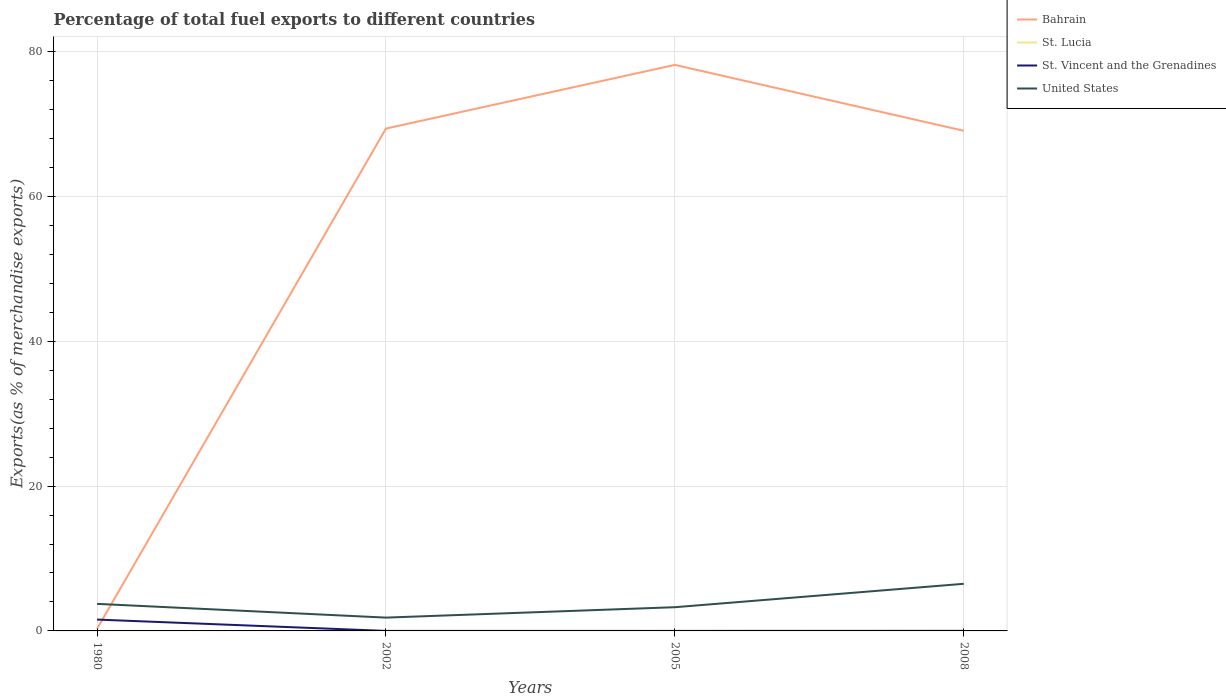How many different coloured lines are there?
Provide a short and direct response. 4. Does the line corresponding to Bahrain intersect with the line corresponding to United States?
Keep it short and to the point. Yes. Across all years, what is the maximum percentage of exports to different countries in United States?
Offer a very short reply. 1.84. What is the total percentage of exports to different countries in St. Lucia in the graph?
Offer a very short reply. -0.02. What is the difference between the highest and the second highest percentage of exports to different countries in St. Vincent and the Grenadines?
Keep it short and to the point. 1.57. Is the percentage of exports to different countries in Bahrain strictly greater than the percentage of exports to different countries in St. Lucia over the years?
Keep it short and to the point. No. Are the values on the major ticks of Y-axis written in scientific E-notation?
Offer a very short reply. No. Does the graph contain any zero values?
Offer a terse response. No. How many legend labels are there?
Make the answer very short. 4. What is the title of the graph?
Provide a short and direct response. Percentage of total fuel exports to different countries. Does "Middle East & North Africa (developing only)" appear as one of the legend labels in the graph?
Make the answer very short. No. What is the label or title of the X-axis?
Provide a succinct answer. Years. What is the label or title of the Y-axis?
Offer a very short reply. Exports(as % of merchandise exports). What is the Exports(as % of merchandise exports) in Bahrain in 1980?
Ensure brevity in your answer.  0.29. What is the Exports(as % of merchandise exports) of St. Lucia in 1980?
Your answer should be compact. 0.01. What is the Exports(as % of merchandise exports) of St. Vincent and the Grenadines in 1980?
Ensure brevity in your answer.  1.57. What is the Exports(as % of merchandise exports) in United States in 1980?
Your answer should be very brief. 3.74. What is the Exports(as % of merchandise exports) of Bahrain in 2002?
Make the answer very short. 69.37. What is the Exports(as % of merchandise exports) of St. Lucia in 2002?
Your answer should be compact. 4.657797227082891e-6. What is the Exports(as % of merchandise exports) in St. Vincent and the Grenadines in 2002?
Provide a short and direct response. 0. What is the Exports(as % of merchandise exports) in United States in 2002?
Make the answer very short. 1.84. What is the Exports(as % of merchandise exports) in Bahrain in 2005?
Offer a very short reply. 78.16. What is the Exports(as % of merchandise exports) in St. Lucia in 2005?
Your response must be concise. 0. What is the Exports(as % of merchandise exports) in St. Vincent and the Grenadines in 2005?
Ensure brevity in your answer.  0. What is the Exports(as % of merchandise exports) of United States in 2005?
Provide a succinct answer. 3.27. What is the Exports(as % of merchandise exports) in Bahrain in 2008?
Provide a short and direct response. 69.06. What is the Exports(as % of merchandise exports) of St. Lucia in 2008?
Provide a succinct answer. 0.02. What is the Exports(as % of merchandise exports) in St. Vincent and the Grenadines in 2008?
Your response must be concise. 0.01. What is the Exports(as % of merchandise exports) of United States in 2008?
Your answer should be compact. 6.51. Across all years, what is the maximum Exports(as % of merchandise exports) of Bahrain?
Give a very brief answer. 78.16. Across all years, what is the maximum Exports(as % of merchandise exports) of St. Lucia?
Your answer should be compact. 0.02. Across all years, what is the maximum Exports(as % of merchandise exports) of St. Vincent and the Grenadines?
Provide a succinct answer. 1.57. Across all years, what is the maximum Exports(as % of merchandise exports) in United States?
Provide a succinct answer. 6.51. Across all years, what is the minimum Exports(as % of merchandise exports) in Bahrain?
Offer a terse response. 0.29. Across all years, what is the minimum Exports(as % of merchandise exports) in St. Lucia?
Offer a terse response. 4.657797227082891e-6. Across all years, what is the minimum Exports(as % of merchandise exports) of St. Vincent and the Grenadines?
Provide a short and direct response. 0. Across all years, what is the minimum Exports(as % of merchandise exports) in United States?
Ensure brevity in your answer.  1.84. What is the total Exports(as % of merchandise exports) in Bahrain in the graph?
Provide a short and direct response. 216.88. What is the total Exports(as % of merchandise exports) of St. Lucia in the graph?
Give a very brief answer. 0.03. What is the total Exports(as % of merchandise exports) of St. Vincent and the Grenadines in the graph?
Make the answer very short. 1.58. What is the total Exports(as % of merchandise exports) of United States in the graph?
Ensure brevity in your answer.  15.35. What is the difference between the Exports(as % of merchandise exports) in Bahrain in 1980 and that in 2002?
Provide a short and direct response. -69.08. What is the difference between the Exports(as % of merchandise exports) in St. Lucia in 1980 and that in 2002?
Offer a very short reply. 0.01. What is the difference between the Exports(as % of merchandise exports) in St. Vincent and the Grenadines in 1980 and that in 2002?
Provide a succinct answer. 1.57. What is the difference between the Exports(as % of merchandise exports) in United States in 1980 and that in 2002?
Provide a succinct answer. 1.9. What is the difference between the Exports(as % of merchandise exports) in Bahrain in 1980 and that in 2005?
Your answer should be compact. -77.87. What is the difference between the Exports(as % of merchandise exports) in St. Lucia in 1980 and that in 2005?
Keep it short and to the point. 0. What is the difference between the Exports(as % of merchandise exports) in St. Vincent and the Grenadines in 1980 and that in 2005?
Give a very brief answer. 1.57. What is the difference between the Exports(as % of merchandise exports) in United States in 1980 and that in 2005?
Offer a very short reply. 0.46. What is the difference between the Exports(as % of merchandise exports) of Bahrain in 1980 and that in 2008?
Provide a short and direct response. -68.77. What is the difference between the Exports(as % of merchandise exports) in St. Lucia in 1980 and that in 2008?
Your answer should be very brief. -0.02. What is the difference between the Exports(as % of merchandise exports) of St. Vincent and the Grenadines in 1980 and that in 2008?
Offer a very short reply. 1.56. What is the difference between the Exports(as % of merchandise exports) in United States in 1980 and that in 2008?
Provide a short and direct response. -2.77. What is the difference between the Exports(as % of merchandise exports) of Bahrain in 2002 and that in 2005?
Your response must be concise. -8.79. What is the difference between the Exports(as % of merchandise exports) of St. Lucia in 2002 and that in 2005?
Keep it short and to the point. -0. What is the difference between the Exports(as % of merchandise exports) of St. Vincent and the Grenadines in 2002 and that in 2005?
Provide a short and direct response. 0. What is the difference between the Exports(as % of merchandise exports) in United States in 2002 and that in 2005?
Offer a terse response. -1.44. What is the difference between the Exports(as % of merchandise exports) in Bahrain in 2002 and that in 2008?
Your answer should be very brief. 0.3. What is the difference between the Exports(as % of merchandise exports) in St. Lucia in 2002 and that in 2008?
Offer a terse response. -0.02. What is the difference between the Exports(as % of merchandise exports) of St. Vincent and the Grenadines in 2002 and that in 2008?
Provide a succinct answer. -0.01. What is the difference between the Exports(as % of merchandise exports) in United States in 2002 and that in 2008?
Offer a very short reply. -4.67. What is the difference between the Exports(as % of merchandise exports) in Bahrain in 2005 and that in 2008?
Provide a short and direct response. 9.1. What is the difference between the Exports(as % of merchandise exports) of St. Lucia in 2005 and that in 2008?
Offer a very short reply. -0.02. What is the difference between the Exports(as % of merchandise exports) in St. Vincent and the Grenadines in 2005 and that in 2008?
Keep it short and to the point. -0.01. What is the difference between the Exports(as % of merchandise exports) in United States in 2005 and that in 2008?
Your answer should be very brief. -3.23. What is the difference between the Exports(as % of merchandise exports) of Bahrain in 1980 and the Exports(as % of merchandise exports) of St. Lucia in 2002?
Ensure brevity in your answer.  0.29. What is the difference between the Exports(as % of merchandise exports) of Bahrain in 1980 and the Exports(as % of merchandise exports) of St. Vincent and the Grenadines in 2002?
Offer a very short reply. 0.29. What is the difference between the Exports(as % of merchandise exports) in Bahrain in 1980 and the Exports(as % of merchandise exports) in United States in 2002?
Keep it short and to the point. -1.55. What is the difference between the Exports(as % of merchandise exports) in St. Lucia in 1980 and the Exports(as % of merchandise exports) in St. Vincent and the Grenadines in 2002?
Provide a short and direct response. 0. What is the difference between the Exports(as % of merchandise exports) in St. Lucia in 1980 and the Exports(as % of merchandise exports) in United States in 2002?
Give a very brief answer. -1.83. What is the difference between the Exports(as % of merchandise exports) of St. Vincent and the Grenadines in 1980 and the Exports(as % of merchandise exports) of United States in 2002?
Your answer should be very brief. -0.27. What is the difference between the Exports(as % of merchandise exports) in Bahrain in 1980 and the Exports(as % of merchandise exports) in St. Lucia in 2005?
Your answer should be very brief. 0.29. What is the difference between the Exports(as % of merchandise exports) in Bahrain in 1980 and the Exports(as % of merchandise exports) in St. Vincent and the Grenadines in 2005?
Keep it short and to the point. 0.29. What is the difference between the Exports(as % of merchandise exports) of Bahrain in 1980 and the Exports(as % of merchandise exports) of United States in 2005?
Ensure brevity in your answer.  -2.98. What is the difference between the Exports(as % of merchandise exports) in St. Lucia in 1980 and the Exports(as % of merchandise exports) in St. Vincent and the Grenadines in 2005?
Your response must be concise. 0.01. What is the difference between the Exports(as % of merchandise exports) in St. Lucia in 1980 and the Exports(as % of merchandise exports) in United States in 2005?
Your response must be concise. -3.27. What is the difference between the Exports(as % of merchandise exports) in St. Vincent and the Grenadines in 1980 and the Exports(as % of merchandise exports) in United States in 2005?
Provide a short and direct response. -1.71. What is the difference between the Exports(as % of merchandise exports) in Bahrain in 1980 and the Exports(as % of merchandise exports) in St. Lucia in 2008?
Give a very brief answer. 0.27. What is the difference between the Exports(as % of merchandise exports) of Bahrain in 1980 and the Exports(as % of merchandise exports) of St. Vincent and the Grenadines in 2008?
Give a very brief answer. 0.28. What is the difference between the Exports(as % of merchandise exports) of Bahrain in 1980 and the Exports(as % of merchandise exports) of United States in 2008?
Give a very brief answer. -6.22. What is the difference between the Exports(as % of merchandise exports) in St. Lucia in 1980 and the Exports(as % of merchandise exports) in St. Vincent and the Grenadines in 2008?
Give a very brief answer. -0. What is the difference between the Exports(as % of merchandise exports) in St. Lucia in 1980 and the Exports(as % of merchandise exports) in United States in 2008?
Make the answer very short. -6.5. What is the difference between the Exports(as % of merchandise exports) of St. Vincent and the Grenadines in 1980 and the Exports(as % of merchandise exports) of United States in 2008?
Provide a succinct answer. -4.94. What is the difference between the Exports(as % of merchandise exports) in Bahrain in 2002 and the Exports(as % of merchandise exports) in St. Lucia in 2005?
Keep it short and to the point. 69.37. What is the difference between the Exports(as % of merchandise exports) in Bahrain in 2002 and the Exports(as % of merchandise exports) in St. Vincent and the Grenadines in 2005?
Provide a short and direct response. 69.37. What is the difference between the Exports(as % of merchandise exports) of Bahrain in 2002 and the Exports(as % of merchandise exports) of United States in 2005?
Offer a terse response. 66.09. What is the difference between the Exports(as % of merchandise exports) of St. Lucia in 2002 and the Exports(as % of merchandise exports) of St. Vincent and the Grenadines in 2005?
Give a very brief answer. -0. What is the difference between the Exports(as % of merchandise exports) of St. Lucia in 2002 and the Exports(as % of merchandise exports) of United States in 2005?
Your answer should be compact. -3.27. What is the difference between the Exports(as % of merchandise exports) of St. Vincent and the Grenadines in 2002 and the Exports(as % of merchandise exports) of United States in 2005?
Your answer should be very brief. -3.27. What is the difference between the Exports(as % of merchandise exports) in Bahrain in 2002 and the Exports(as % of merchandise exports) in St. Lucia in 2008?
Provide a short and direct response. 69.34. What is the difference between the Exports(as % of merchandise exports) in Bahrain in 2002 and the Exports(as % of merchandise exports) in St. Vincent and the Grenadines in 2008?
Your answer should be very brief. 69.36. What is the difference between the Exports(as % of merchandise exports) in Bahrain in 2002 and the Exports(as % of merchandise exports) in United States in 2008?
Offer a very short reply. 62.86. What is the difference between the Exports(as % of merchandise exports) of St. Lucia in 2002 and the Exports(as % of merchandise exports) of St. Vincent and the Grenadines in 2008?
Make the answer very short. -0.01. What is the difference between the Exports(as % of merchandise exports) of St. Lucia in 2002 and the Exports(as % of merchandise exports) of United States in 2008?
Ensure brevity in your answer.  -6.51. What is the difference between the Exports(as % of merchandise exports) in St. Vincent and the Grenadines in 2002 and the Exports(as % of merchandise exports) in United States in 2008?
Offer a very short reply. -6.5. What is the difference between the Exports(as % of merchandise exports) of Bahrain in 2005 and the Exports(as % of merchandise exports) of St. Lucia in 2008?
Offer a very short reply. 78.13. What is the difference between the Exports(as % of merchandise exports) of Bahrain in 2005 and the Exports(as % of merchandise exports) of St. Vincent and the Grenadines in 2008?
Your answer should be compact. 78.15. What is the difference between the Exports(as % of merchandise exports) in Bahrain in 2005 and the Exports(as % of merchandise exports) in United States in 2008?
Your answer should be very brief. 71.65. What is the difference between the Exports(as % of merchandise exports) in St. Lucia in 2005 and the Exports(as % of merchandise exports) in St. Vincent and the Grenadines in 2008?
Keep it short and to the point. -0.01. What is the difference between the Exports(as % of merchandise exports) of St. Lucia in 2005 and the Exports(as % of merchandise exports) of United States in 2008?
Ensure brevity in your answer.  -6.51. What is the difference between the Exports(as % of merchandise exports) in St. Vincent and the Grenadines in 2005 and the Exports(as % of merchandise exports) in United States in 2008?
Your response must be concise. -6.51. What is the average Exports(as % of merchandise exports) in Bahrain per year?
Keep it short and to the point. 54.22. What is the average Exports(as % of merchandise exports) in St. Lucia per year?
Offer a very short reply. 0.01. What is the average Exports(as % of merchandise exports) of St. Vincent and the Grenadines per year?
Provide a short and direct response. 0.39. What is the average Exports(as % of merchandise exports) of United States per year?
Your answer should be compact. 3.84. In the year 1980, what is the difference between the Exports(as % of merchandise exports) in Bahrain and Exports(as % of merchandise exports) in St. Lucia?
Ensure brevity in your answer.  0.29. In the year 1980, what is the difference between the Exports(as % of merchandise exports) in Bahrain and Exports(as % of merchandise exports) in St. Vincent and the Grenadines?
Ensure brevity in your answer.  -1.28. In the year 1980, what is the difference between the Exports(as % of merchandise exports) in Bahrain and Exports(as % of merchandise exports) in United States?
Keep it short and to the point. -3.45. In the year 1980, what is the difference between the Exports(as % of merchandise exports) of St. Lucia and Exports(as % of merchandise exports) of St. Vincent and the Grenadines?
Your answer should be compact. -1.56. In the year 1980, what is the difference between the Exports(as % of merchandise exports) of St. Lucia and Exports(as % of merchandise exports) of United States?
Make the answer very short. -3.73. In the year 1980, what is the difference between the Exports(as % of merchandise exports) of St. Vincent and the Grenadines and Exports(as % of merchandise exports) of United States?
Offer a very short reply. -2.17. In the year 2002, what is the difference between the Exports(as % of merchandise exports) in Bahrain and Exports(as % of merchandise exports) in St. Lucia?
Your response must be concise. 69.37. In the year 2002, what is the difference between the Exports(as % of merchandise exports) in Bahrain and Exports(as % of merchandise exports) in St. Vincent and the Grenadines?
Make the answer very short. 69.36. In the year 2002, what is the difference between the Exports(as % of merchandise exports) in Bahrain and Exports(as % of merchandise exports) in United States?
Offer a terse response. 67.53. In the year 2002, what is the difference between the Exports(as % of merchandise exports) in St. Lucia and Exports(as % of merchandise exports) in St. Vincent and the Grenadines?
Keep it short and to the point. -0. In the year 2002, what is the difference between the Exports(as % of merchandise exports) of St. Lucia and Exports(as % of merchandise exports) of United States?
Ensure brevity in your answer.  -1.84. In the year 2002, what is the difference between the Exports(as % of merchandise exports) in St. Vincent and the Grenadines and Exports(as % of merchandise exports) in United States?
Your answer should be compact. -1.84. In the year 2005, what is the difference between the Exports(as % of merchandise exports) of Bahrain and Exports(as % of merchandise exports) of St. Lucia?
Your response must be concise. 78.16. In the year 2005, what is the difference between the Exports(as % of merchandise exports) in Bahrain and Exports(as % of merchandise exports) in St. Vincent and the Grenadines?
Offer a very short reply. 78.16. In the year 2005, what is the difference between the Exports(as % of merchandise exports) in Bahrain and Exports(as % of merchandise exports) in United States?
Offer a terse response. 74.88. In the year 2005, what is the difference between the Exports(as % of merchandise exports) in St. Lucia and Exports(as % of merchandise exports) in St. Vincent and the Grenadines?
Your answer should be compact. 0. In the year 2005, what is the difference between the Exports(as % of merchandise exports) in St. Lucia and Exports(as % of merchandise exports) in United States?
Your response must be concise. -3.27. In the year 2005, what is the difference between the Exports(as % of merchandise exports) of St. Vincent and the Grenadines and Exports(as % of merchandise exports) of United States?
Ensure brevity in your answer.  -3.27. In the year 2008, what is the difference between the Exports(as % of merchandise exports) in Bahrain and Exports(as % of merchandise exports) in St. Lucia?
Provide a succinct answer. 69.04. In the year 2008, what is the difference between the Exports(as % of merchandise exports) in Bahrain and Exports(as % of merchandise exports) in St. Vincent and the Grenadines?
Offer a very short reply. 69.05. In the year 2008, what is the difference between the Exports(as % of merchandise exports) in Bahrain and Exports(as % of merchandise exports) in United States?
Provide a succinct answer. 62.56. In the year 2008, what is the difference between the Exports(as % of merchandise exports) of St. Lucia and Exports(as % of merchandise exports) of St. Vincent and the Grenadines?
Make the answer very short. 0.02. In the year 2008, what is the difference between the Exports(as % of merchandise exports) in St. Lucia and Exports(as % of merchandise exports) in United States?
Give a very brief answer. -6.48. In the year 2008, what is the difference between the Exports(as % of merchandise exports) of St. Vincent and the Grenadines and Exports(as % of merchandise exports) of United States?
Your answer should be very brief. -6.5. What is the ratio of the Exports(as % of merchandise exports) of Bahrain in 1980 to that in 2002?
Offer a very short reply. 0. What is the ratio of the Exports(as % of merchandise exports) in St. Lucia in 1980 to that in 2002?
Ensure brevity in your answer.  1142.2. What is the ratio of the Exports(as % of merchandise exports) of St. Vincent and the Grenadines in 1980 to that in 2002?
Offer a very short reply. 876.44. What is the ratio of the Exports(as % of merchandise exports) in United States in 1980 to that in 2002?
Give a very brief answer. 2.03. What is the ratio of the Exports(as % of merchandise exports) of Bahrain in 1980 to that in 2005?
Your response must be concise. 0. What is the ratio of the Exports(as % of merchandise exports) in St. Lucia in 1980 to that in 2005?
Give a very brief answer. 5.29. What is the ratio of the Exports(as % of merchandise exports) in St. Vincent and the Grenadines in 1980 to that in 2005?
Provide a short and direct response. 4746.5. What is the ratio of the Exports(as % of merchandise exports) in United States in 1980 to that in 2005?
Provide a short and direct response. 1.14. What is the ratio of the Exports(as % of merchandise exports) of Bahrain in 1980 to that in 2008?
Make the answer very short. 0. What is the ratio of the Exports(as % of merchandise exports) of St. Lucia in 1980 to that in 2008?
Your answer should be compact. 0.22. What is the ratio of the Exports(as % of merchandise exports) in St. Vincent and the Grenadines in 1980 to that in 2008?
Offer a terse response. 169.92. What is the ratio of the Exports(as % of merchandise exports) in United States in 1980 to that in 2008?
Your answer should be compact. 0.57. What is the ratio of the Exports(as % of merchandise exports) in Bahrain in 2002 to that in 2005?
Make the answer very short. 0.89. What is the ratio of the Exports(as % of merchandise exports) of St. Lucia in 2002 to that in 2005?
Your response must be concise. 0. What is the ratio of the Exports(as % of merchandise exports) in St. Vincent and the Grenadines in 2002 to that in 2005?
Your response must be concise. 5.42. What is the ratio of the Exports(as % of merchandise exports) in United States in 2002 to that in 2005?
Your answer should be very brief. 0.56. What is the ratio of the Exports(as % of merchandise exports) in Bahrain in 2002 to that in 2008?
Keep it short and to the point. 1. What is the ratio of the Exports(as % of merchandise exports) in St. Lucia in 2002 to that in 2008?
Make the answer very short. 0. What is the ratio of the Exports(as % of merchandise exports) of St. Vincent and the Grenadines in 2002 to that in 2008?
Your response must be concise. 0.19. What is the ratio of the Exports(as % of merchandise exports) of United States in 2002 to that in 2008?
Provide a short and direct response. 0.28. What is the ratio of the Exports(as % of merchandise exports) of Bahrain in 2005 to that in 2008?
Your response must be concise. 1.13. What is the ratio of the Exports(as % of merchandise exports) of St. Lucia in 2005 to that in 2008?
Your response must be concise. 0.04. What is the ratio of the Exports(as % of merchandise exports) of St. Vincent and the Grenadines in 2005 to that in 2008?
Ensure brevity in your answer.  0.04. What is the ratio of the Exports(as % of merchandise exports) in United States in 2005 to that in 2008?
Make the answer very short. 0.5. What is the difference between the highest and the second highest Exports(as % of merchandise exports) in Bahrain?
Your answer should be very brief. 8.79. What is the difference between the highest and the second highest Exports(as % of merchandise exports) of St. Lucia?
Make the answer very short. 0.02. What is the difference between the highest and the second highest Exports(as % of merchandise exports) in St. Vincent and the Grenadines?
Your response must be concise. 1.56. What is the difference between the highest and the second highest Exports(as % of merchandise exports) in United States?
Your answer should be very brief. 2.77. What is the difference between the highest and the lowest Exports(as % of merchandise exports) of Bahrain?
Provide a succinct answer. 77.87. What is the difference between the highest and the lowest Exports(as % of merchandise exports) in St. Lucia?
Offer a very short reply. 0.02. What is the difference between the highest and the lowest Exports(as % of merchandise exports) in St. Vincent and the Grenadines?
Your response must be concise. 1.57. What is the difference between the highest and the lowest Exports(as % of merchandise exports) of United States?
Your answer should be very brief. 4.67. 